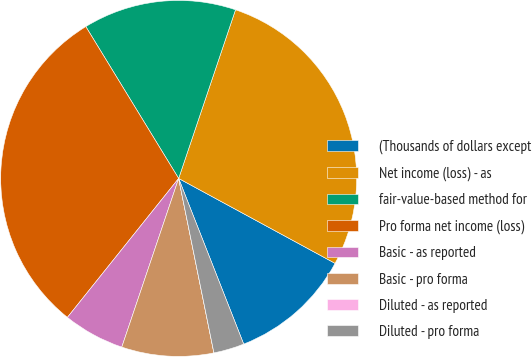Convert chart. <chart><loc_0><loc_0><loc_500><loc_500><pie_chart><fcel>(Thousands of dollars except<fcel>Net income (loss) - as<fcel>fair-value-based method for<fcel>Pro forma net income (loss)<fcel>Basic - as reported<fcel>Basic - pro forma<fcel>Diluted - as reported<fcel>Diluted - pro forma<nl><fcel>11.13%<fcel>27.74%<fcel>13.91%<fcel>30.52%<fcel>5.57%<fcel>8.35%<fcel>0.0%<fcel>2.78%<nl></chart> 